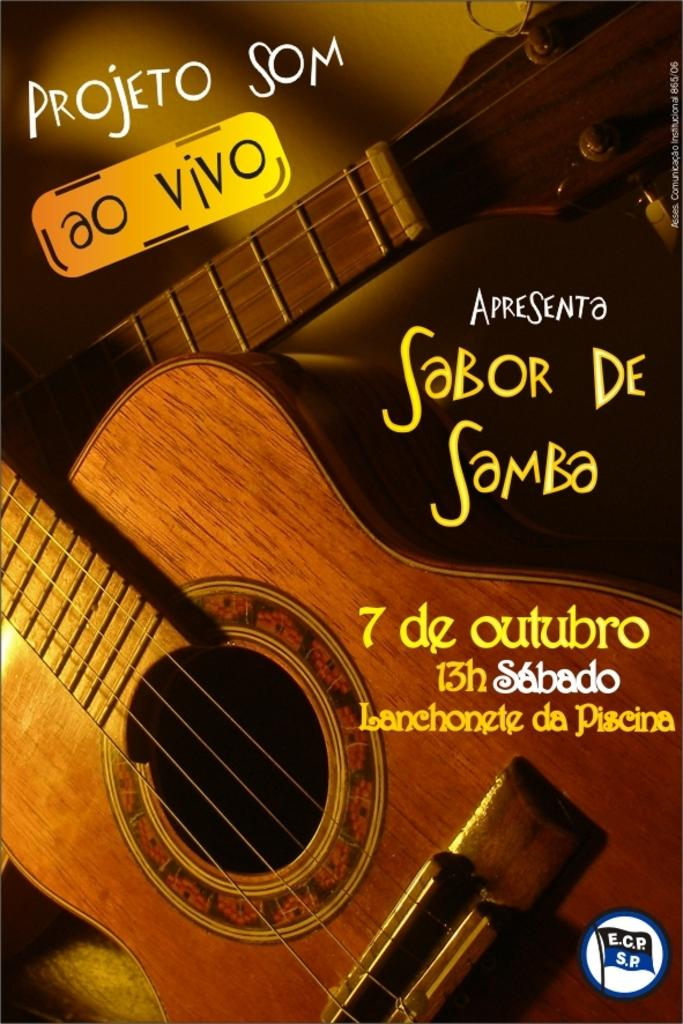What is featured in the picture? There is a poster in the picture. What is shown on the poster? The poster has musical instruments depicted on it. Are there any words on the poster? Yes, there are texts on the poster. What song is being played on the sink in the image? There is no sink or any song being played in the image. 